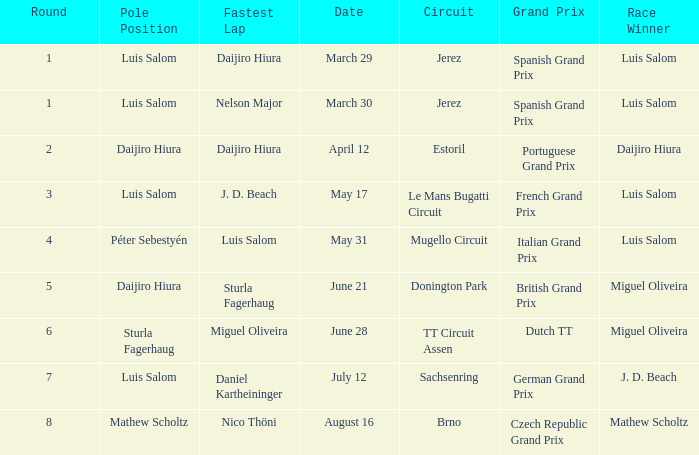Who had the fastest lap in the Dutch TT Grand Prix?  Miguel Oliveira. 